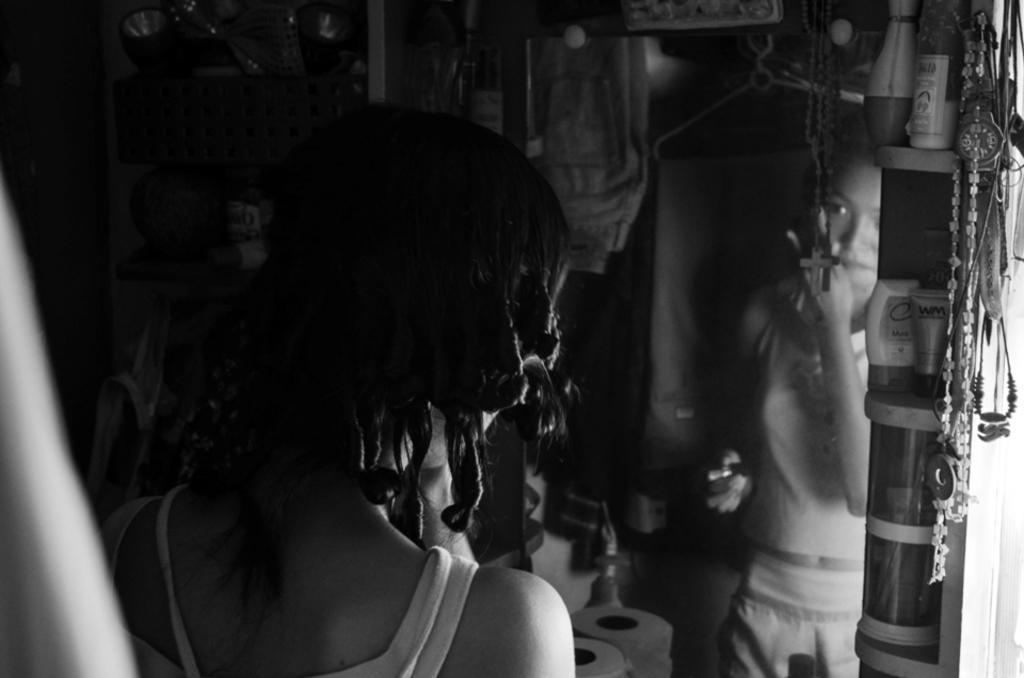Can you describe this image briefly? In the image we can see a woman standing and wearing clothes. There is a mirror, in the mirror, we can see the reflection of this woman. This is a wrist watch, neck chain and other things. 